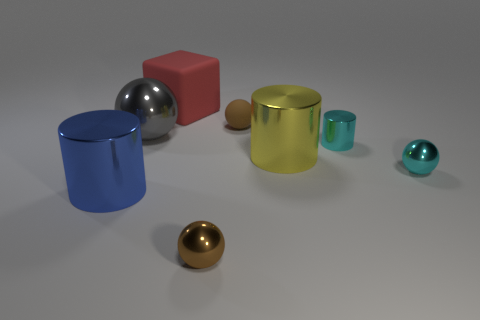How many cubes are big blue things or small things?
Provide a short and direct response. 0. How many big yellow metallic objects are right of the large cylinder that is to the right of the brown metallic ball?
Ensure brevity in your answer.  0. Are the yellow thing and the gray ball made of the same material?
Keep it short and to the point. Yes. What is the size of the object that is the same color as the small shiny cylinder?
Your answer should be compact. Small. Is there a yellow cylinder made of the same material as the blue object?
Provide a succinct answer. Yes. There is a large thing behind the ball that is left of the large object behind the gray ball; what is its color?
Provide a short and direct response. Red. How many gray objects are big shiny spheres or large blocks?
Your answer should be very brief. 1. How many blue things have the same shape as the red rubber object?
Your answer should be very brief. 0. There is a cyan metal object that is the same size as the cyan shiny cylinder; what is its shape?
Offer a very short reply. Sphere. There is a brown shiny sphere; are there any small spheres behind it?
Your response must be concise. Yes. 